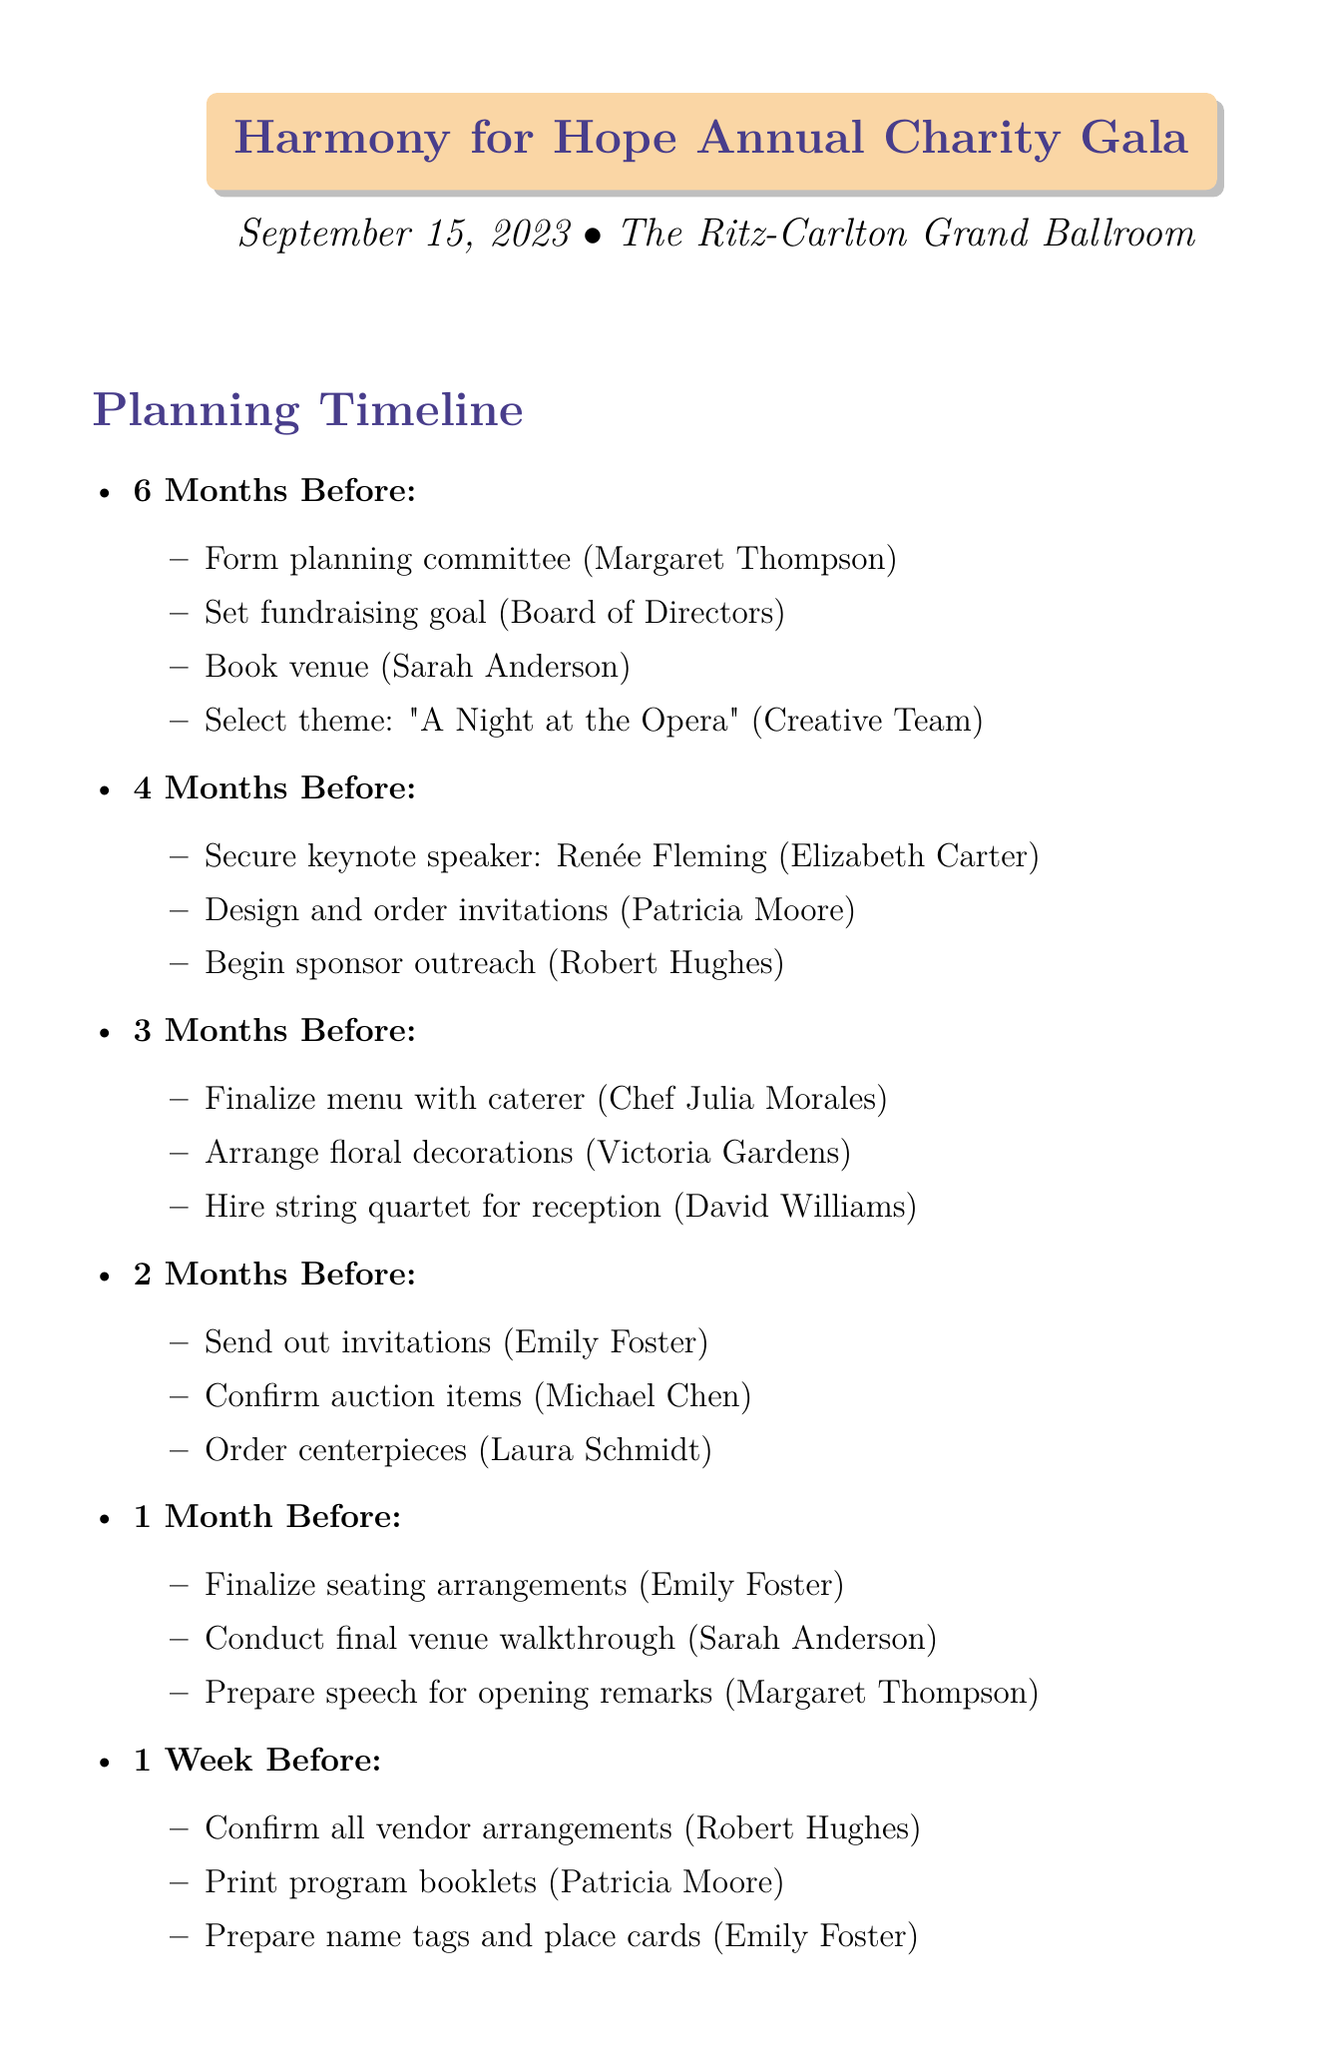What is the event name? The event name is listed at the top of the document.
Answer: Harmony for Hope Annual Charity Gala What is the event date? The event date is mentioned directly below the event name.
Answer: September 15, 2023 Who is the venue coordinator? The venue coordinator is mentioned in the task list for booking the venue.
Answer: Sarah Anderson What is the budget for securing the keynote speaker? The budget is clearly indicated next to the task of securing the keynote speaker.
Answer: $15,000 How many months before the event does the planning phase start? The document states the first planning phase is "6 Months Before."
Answer: 6 Which organization is the beneficiary of the charity gala? The beneficiary is stated in the budget overview section.
Answer: City Symphony Orchestra Youth Education Program What is the fundraising goal? The fundraising goal is provided in the budget overview section.
Answer: $250,000 What theme has been selected for the event? The theme is mentioned as part of the planning timeline.
Answer: A Night at the Opera What is a special consideration regarding entertainment? The special considerations section lists specific requirements regarding entertainment.
Answer: Family-friendly 